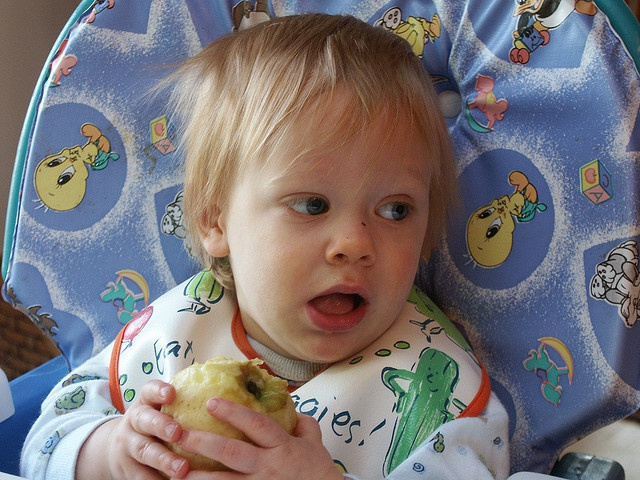Describe the objects in this image and their specific colors. I can see people in gray, darkgray, lightgray, and maroon tones, chair in gray and darkgray tones, and apple in gray, tan, olive, and khaki tones in this image. 